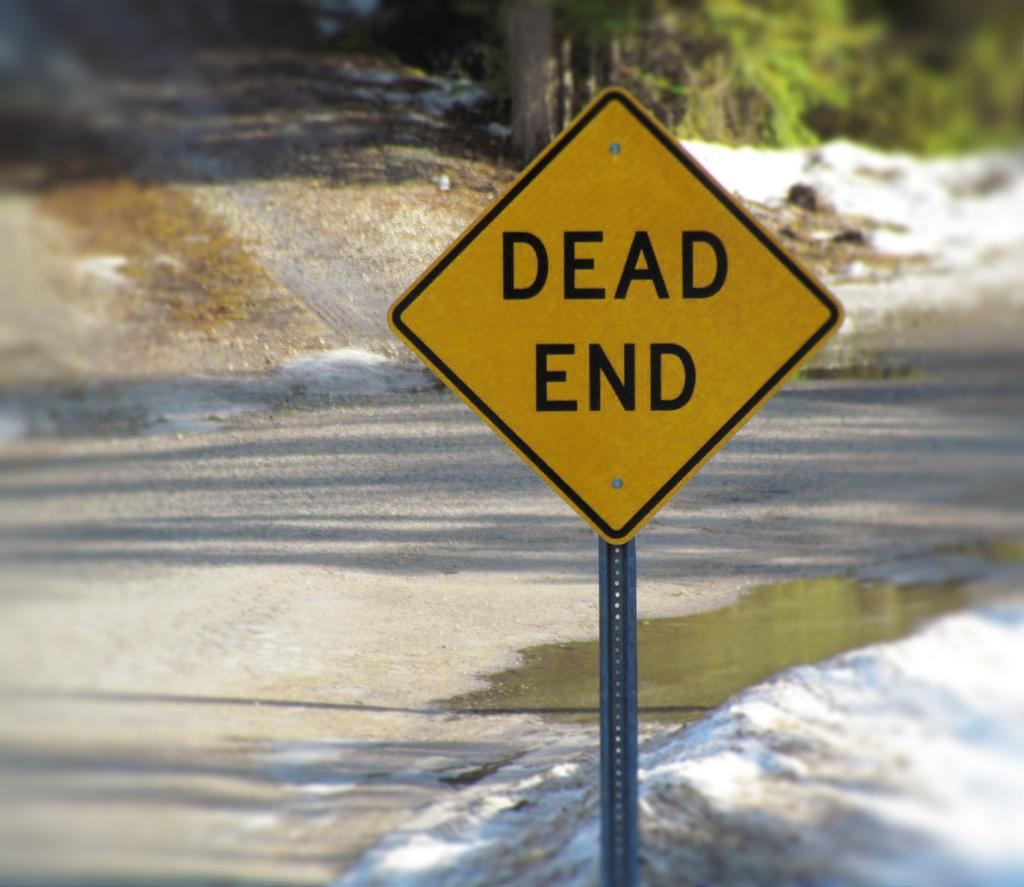<image>
Offer a succinct explanation of the picture presented. A road sign that reads dead end in a bed of slushy snow. 